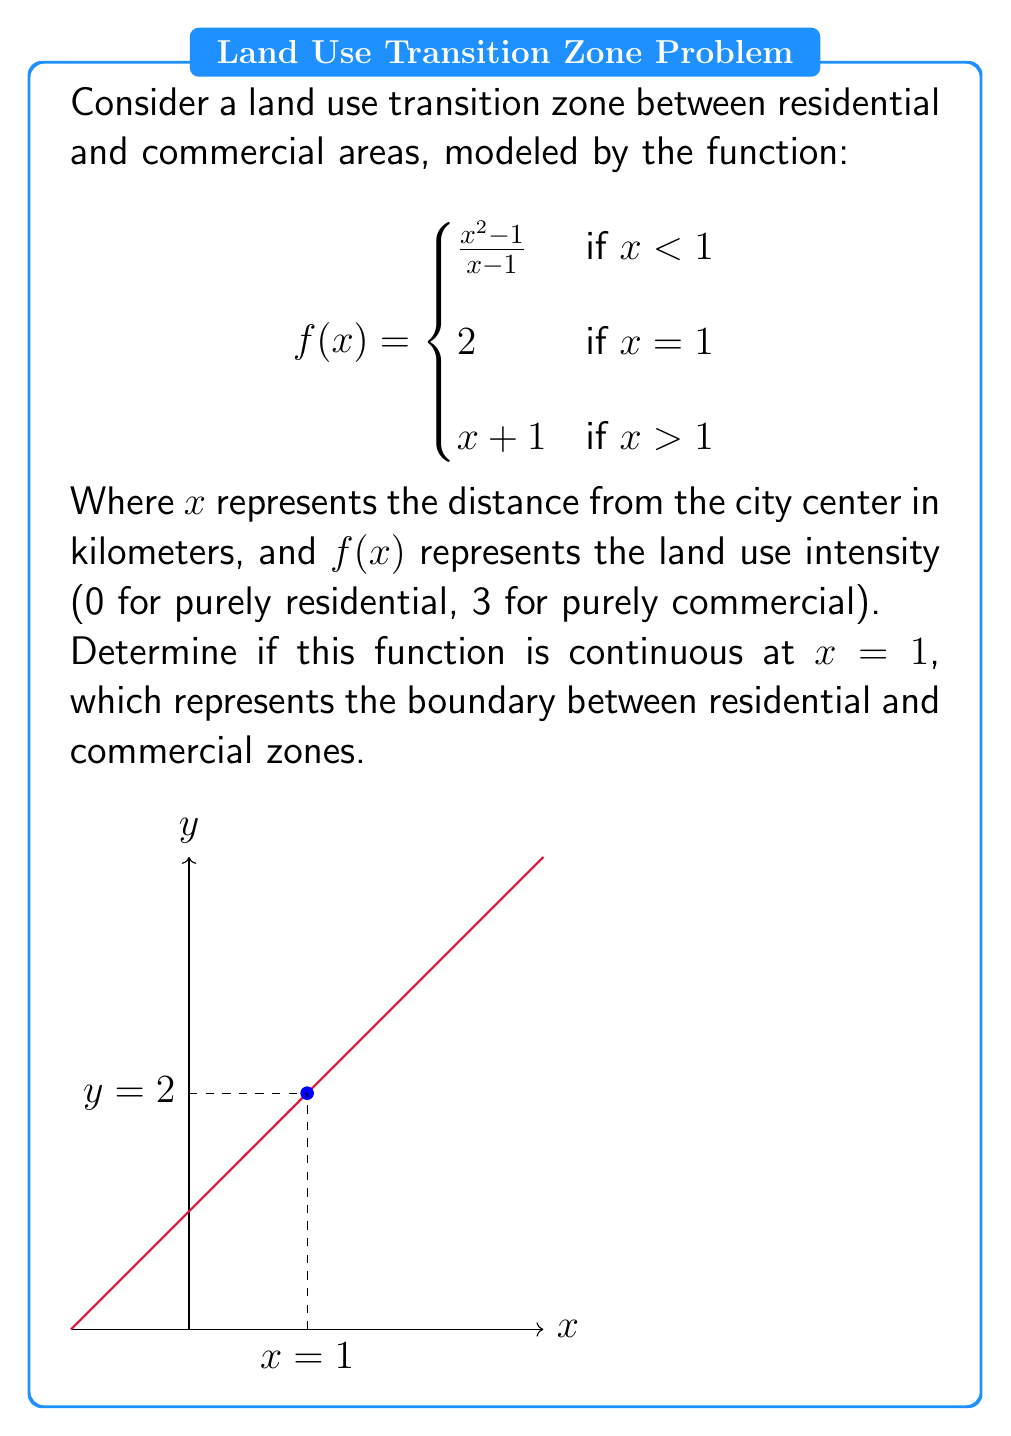Teach me how to tackle this problem. To determine if the function is continuous at $x = 1$, we need to check three conditions:

1. $f(1)$ must be defined.
2. $\lim_{x \to 1^-} f(x)$ must exist.
3. $\lim_{x \to 1^+} f(x)$ must exist.
4. Both limits must equal $f(1)$.

Step 1: Check if $f(1)$ is defined.
$f(1) = 2$ (given in the piecewise function), so it is defined.

Step 2: Calculate $\lim_{x \to 1^-} f(x)$
$$\lim_{x \to 1^-} f(x) = \lim_{x \to 1^-} \frac{x^2 - 1}{x - 1}$$
$$= \lim_{x \to 1^-} \frac{(x+1)(x-1)}{x-1} = \lim_{x \to 1^-} (x+1) = 2$$

Step 3: Calculate $\lim_{x \to 1^+} f(x)$
$$\lim_{x \to 1^+} f(x) = \lim_{x \to 1^+} (x + 1) = 2$$

Step 4: Compare the limits to $f(1)$
Both $\lim_{x \to 1^-} f(x)$ and $\lim_{x \to 1^+} f(x)$ equal 2, which is also equal to $f(1)$.

Therefore, all conditions for continuity at $x = 1$ are satisfied.
Answer: The function is continuous at $x = 1$. 